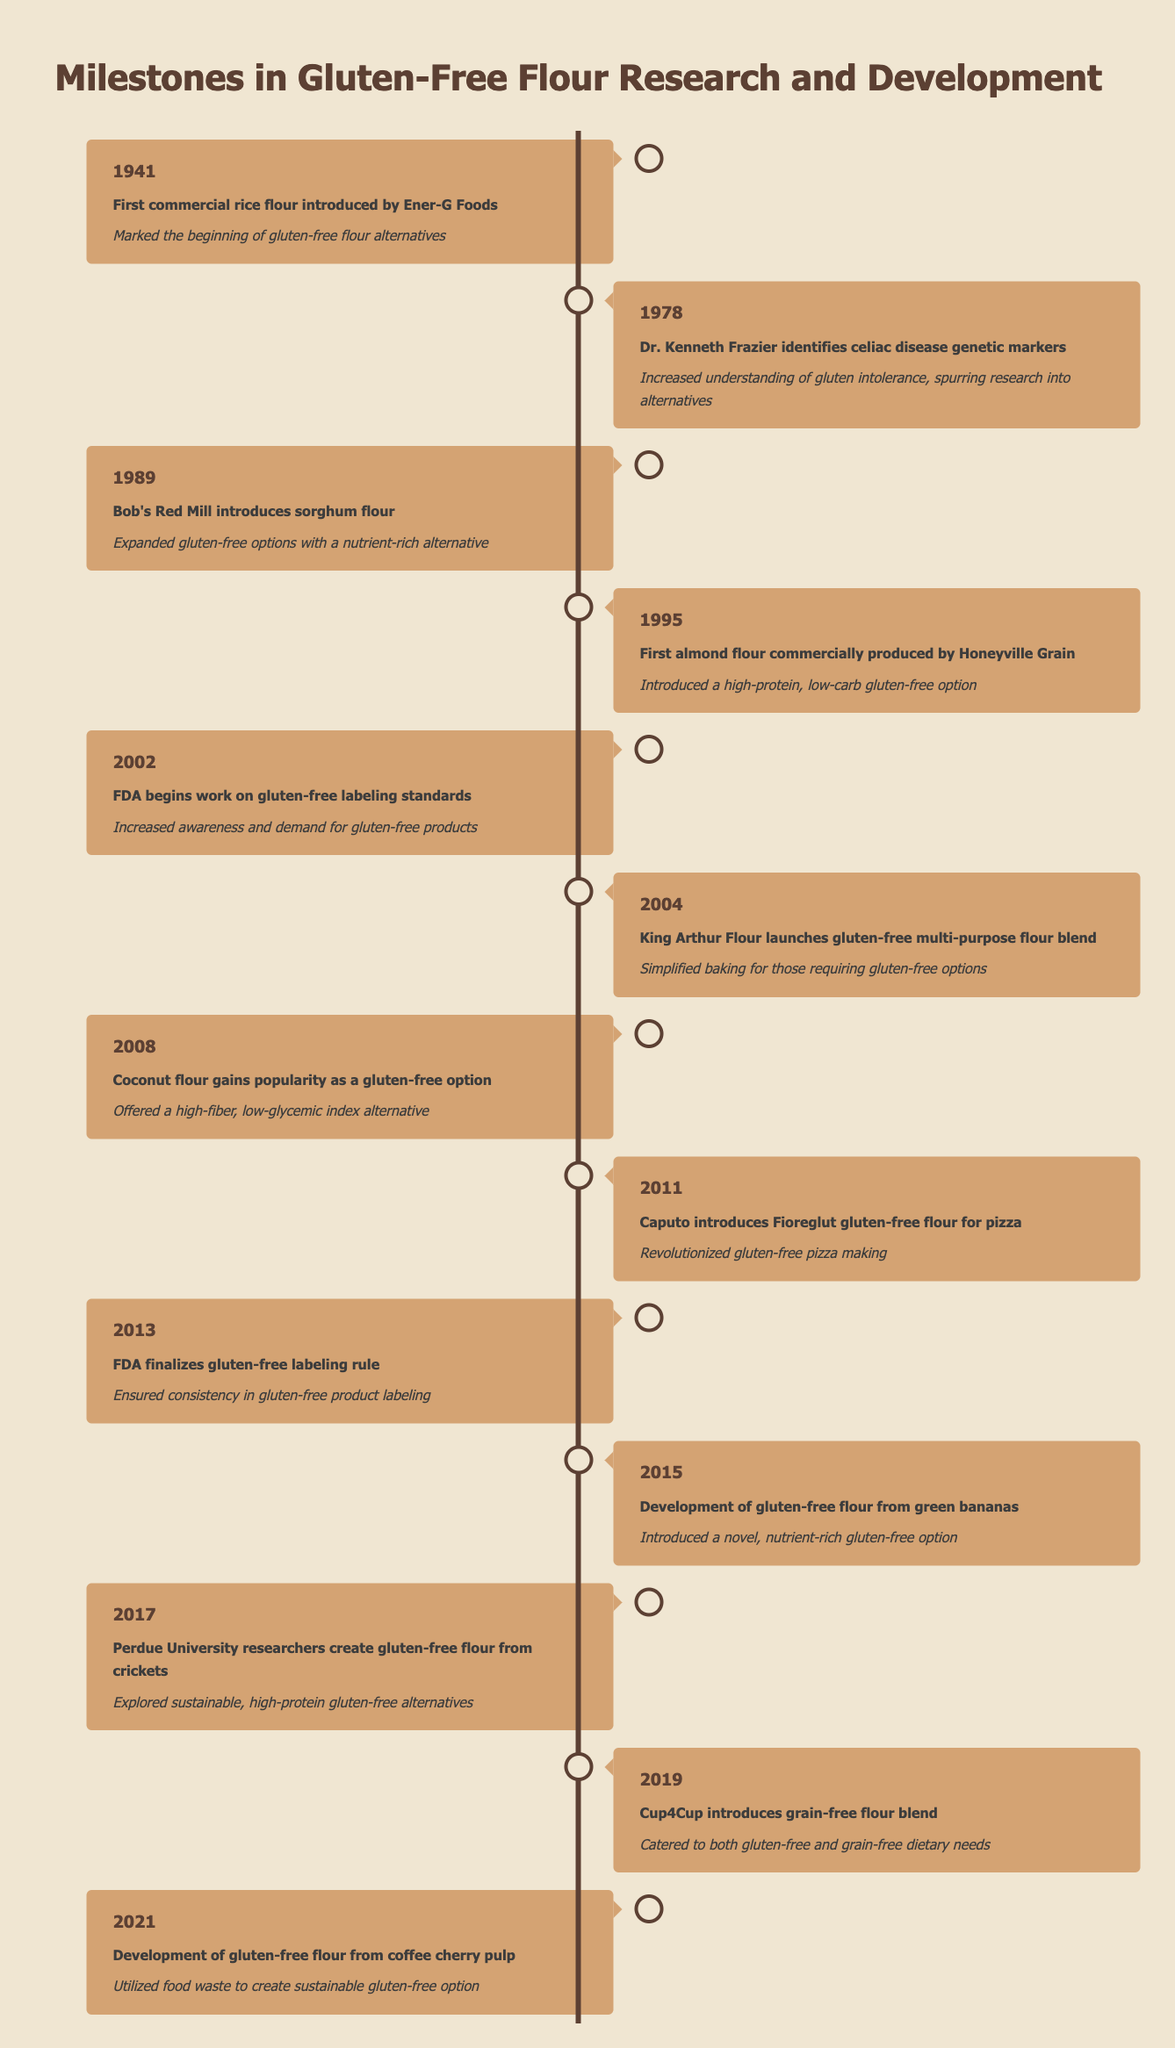What year did the first commercial rice flour get introduced? The table shows the event listed for the year 1941 is the introduction of the first commercial rice flour by Ener-G Foods.
Answer: 1941 Which flour introduced by Bob's Red Mill was notable in 1989? Bob's Red Mill is noted for introducing sorghum flour in 1989 according to the table.
Answer: Sorghum flour Did the FDA begin working on gluten-free labeling standards before or after 2002? The table indicates that the FDA began work on gluten-free labeling standards in 2002, which shows it was not done before that year.
Answer: Before What was the significance of the gluten-free flour introduced in 2015? The introduction of gluten-free flour from green bananas in 2015 marked a novel, nutrient-rich gluten-free option, highlighting advancements in gluten-free research.
Answer: It introduced a novel option How many unique gluten-free flour products or developments were introduced between 2000 and 2021? Counting the unique flour developments listed between 2002 (King Arthur's blend) and 2021 (coffee cherry pulp), there are six distinct products: gluten-free multi-purpose flour blend, popularity of coconut flour, Fioreglut flour for pizza, gluten-free labeling rule, flour from green bananas, and flour from coffee cherry pulp.
Answer: Six Which introduced flour was characterized as a low-glycemic index alternative? According to the table, coconut flour gained popularity in 2008 for being a high-fiber, low-glycemic index alternative.
Answer: Coconut flour Is it true that the development of gluten-free options has a connection to celiac disease research? The table mentions that Dr. Kenneth Frazier identified celiac disease markers in 1978, which increased understanding and research into gluten-free alternatives, establishing a clear connection.
Answer: True What is the most recent event regarding gluten-free flour development listed in the table? The latest event noted in the table is from 2021, which involves the development of gluten-free flour from coffee cherry pulp.
Answer: Development from coffee cherry pulp 